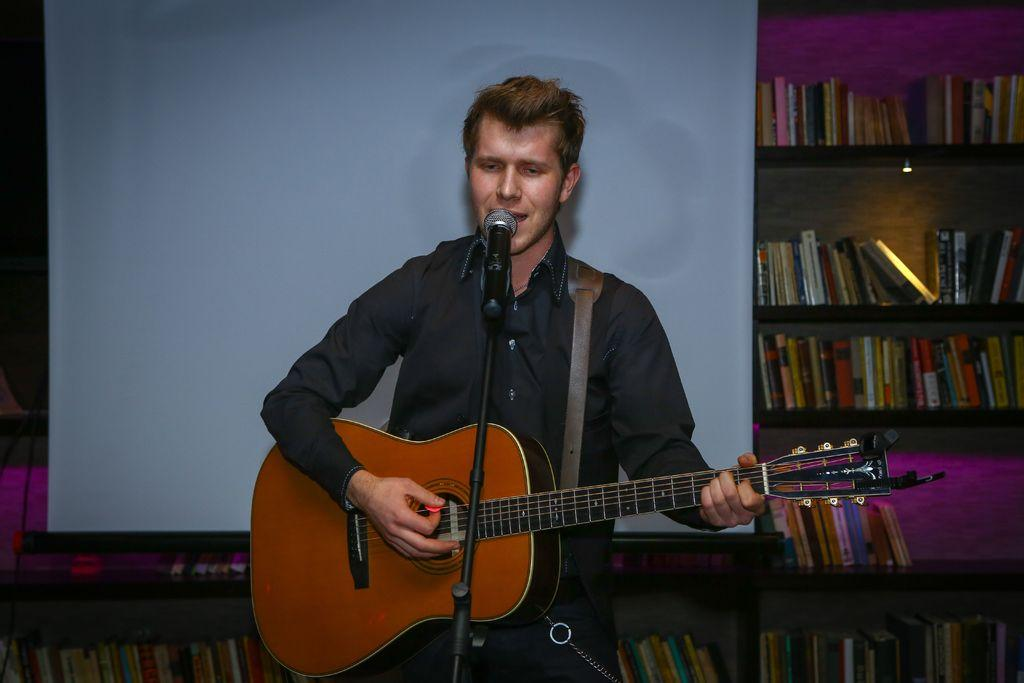What is the person in the image doing? The person is singing and playing a guitar. What is the person wearing? The person is wearing a black shirt. What object is the person using to amplify their voice? The person is in front of a microphone. What can be seen in the background of the image? There is a bookshelf and a projector in the background. What type of cabbage is being used as a veil in the image? There is no cabbage or veil present in the image. 